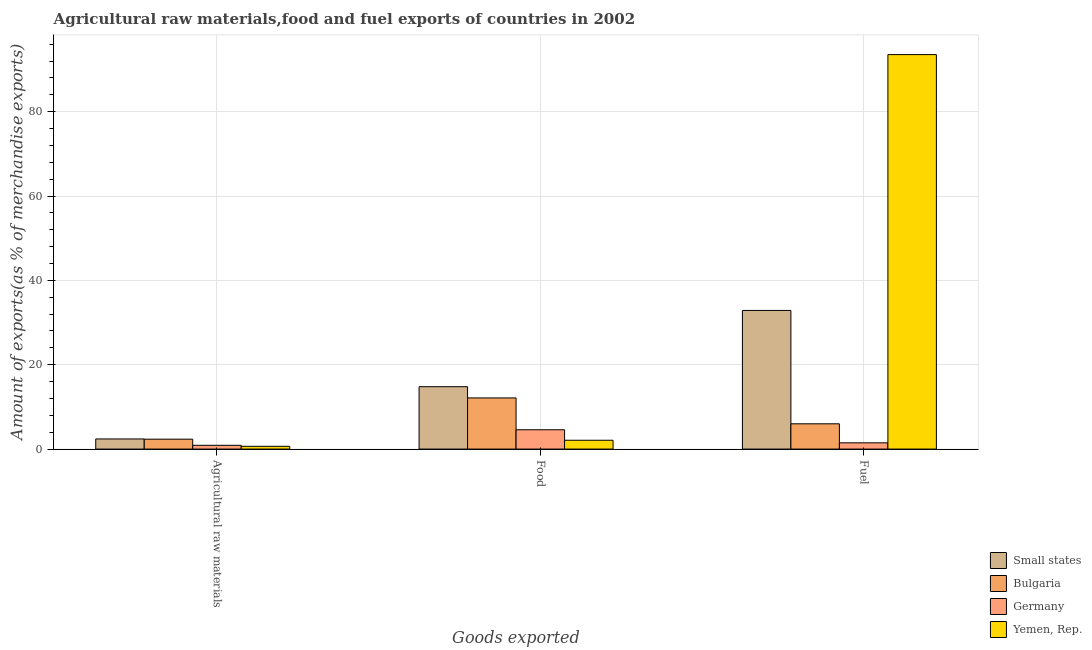How many different coloured bars are there?
Provide a short and direct response. 4. Are the number of bars per tick equal to the number of legend labels?
Provide a short and direct response. Yes. How many bars are there on the 2nd tick from the left?
Provide a short and direct response. 4. What is the label of the 3rd group of bars from the left?
Keep it short and to the point. Fuel. What is the percentage of raw materials exports in Germany?
Give a very brief answer. 0.9. Across all countries, what is the maximum percentage of food exports?
Your response must be concise. 14.79. Across all countries, what is the minimum percentage of fuel exports?
Ensure brevity in your answer.  1.48. In which country was the percentage of raw materials exports maximum?
Provide a succinct answer. Small states. In which country was the percentage of raw materials exports minimum?
Your answer should be very brief. Yemen, Rep. What is the total percentage of raw materials exports in the graph?
Your answer should be compact. 6.3. What is the difference between the percentage of food exports in Bulgaria and that in Germany?
Give a very brief answer. 7.55. What is the difference between the percentage of raw materials exports in Bulgaria and the percentage of food exports in Small states?
Your response must be concise. -12.45. What is the average percentage of food exports per country?
Give a very brief answer. 8.4. What is the difference between the percentage of food exports and percentage of raw materials exports in Bulgaria?
Provide a succinct answer. 9.78. What is the ratio of the percentage of food exports in Yemen, Rep. to that in Germany?
Offer a very short reply. 0.46. Is the percentage of food exports in Small states less than that in Germany?
Offer a very short reply. No. Is the difference between the percentage of food exports in Small states and Bulgaria greater than the difference between the percentage of raw materials exports in Small states and Bulgaria?
Offer a terse response. Yes. What is the difference between the highest and the second highest percentage of fuel exports?
Provide a succinct answer. 60.67. What is the difference between the highest and the lowest percentage of raw materials exports?
Make the answer very short. 1.75. What does the 4th bar from the left in Agricultural raw materials represents?
Offer a very short reply. Yemen, Rep. What does the 4th bar from the right in Fuel represents?
Keep it short and to the point. Small states. Is it the case that in every country, the sum of the percentage of raw materials exports and percentage of food exports is greater than the percentage of fuel exports?
Offer a terse response. No. What is the difference between two consecutive major ticks on the Y-axis?
Make the answer very short. 20. Are the values on the major ticks of Y-axis written in scientific E-notation?
Keep it short and to the point. No. Does the graph contain any zero values?
Give a very brief answer. No. How are the legend labels stacked?
Offer a terse response. Vertical. What is the title of the graph?
Offer a terse response. Agricultural raw materials,food and fuel exports of countries in 2002. What is the label or title of the X-axis?
Offer a very short reply. Goods exported. What is the label or title of the Y-axis?
Your response must be concise. Amount of exports(as % of merchandise exports). What is the Amount of exports(as % of merchandise exports) of Small states in Agricultural raw materials?
Your answer should be compact. 2.4. What is the Amount of exports(as % of merchandise exports) of Bulgaria in Agricultural raw materials?
Provide a short and direct response. 2.35. What is the Amount of exports(as % of merchandise exports) in Germany in Agricultural raw materials?
Your response must be concise. 0.9. What is the Amount of exports(as % of merchandise exports) in Yemen, Rep. in Agricultural raw materials?
Keep it short and to the point. 0.66. What is the Amount of exports(as % of merchandise exports) in Small states in Food?
Make the answer very short. 14.79. What is the Amount of exports(as % of merchandise exports) in Bulgaria in Food?
Give a very brief answer. 12.13. What is the Amount of exports(as % of merchandise exports) in Germany in Food?
Give a very brief answer. 4.58. What is the Amount of exports(as % of merchandise exports) of Yemen, Rep. in Food?
Offer a very short reply. 2.09. What is the Amount of exports(as % of merchandise exports) of Small states in Fuel?
Keep it short and to the point. 32.88. What is the Amount of exports(as % of merchandise exports) of Bulgaria in Fuel?
Your response must be concise. 5.99. What is the Amount of exports(as % of merchandise exports) in Germany in Fuel?
Your answer should be very brief. 1.48. What is the Amount of exports(as % of merchandise exports) in Yemen, Rep. in Fuel?
Ensure brevity in your answer.  93.54. Across all Goods exported, what is the maximum Amount of exports(as % of merchandise exports) of Small states?
Your answer should be compact. 32.88. Across all Goods exported, what is the maximum Amount of exports(as % of merchandise exports) in Bulgaria?
Provide a succinct answer. 12.13. Across all Goods exported, what is the maximum Amount of exports(as % of merchandise exports) in Germany?
Give a very brief answer. 4.58. Across all Goods exported, what is the maximum Amount of exports(as % of merchandise exports) of Yemen, Rep.?
Provide a short and direct response. 93.54. Across all Goods exported, what is the minimum Amount of exports(as % of merchandise exports) of Small states?
Your answer should be very brief. 2.4. Across all Goods exported, what is the minimum Amount of exports(as % of merchandise exports) of Bulgaria?
Make the answer very short. 2.35. Across all Goods exported, what is the minimum Amount of exports(as % of merchandise exports) of Germany?
Give a very brief answer. 0.9. Across all Goods exported, what is the minimum Amount of exports(as % of merchandise exports) in Yemen, Rep.?
Give a very brief answer. 0.66. What is the total Amount of exports(as % of merchandise exports) of Small states in the graph?
Make the answer very short. 50.07. What is the total Amount of exports(as % of merchandise exports) in Bulgaria in the graph?
Your response must be concise. 20.46. What is the total Amount of exports(as % of merchandise exports) in Germany in the graph?
Your response must be concise. 6.96. What is the total Amount of exports(as % of merchandise exports) of Yemen, Rep. in the graph?
Make the answer very short. 96.29. What is the difference between the Amount of exports(as % of merchandise exports) in Small states in Agricultural raw materials and that in Food?
Your response must be concise. -12.39. What is the difference between the Amount of exports(as % of merchandise exports) of Bulgaria in Agricultural raw materials and that in Food?
Keep it short and to the point. -9.78. What is the difference between the Amount of exports(as % of merchandise exports) in Germany in Agricultural raw materials and that in Food?
Your response must be concise. -3.69. What is the difference between the Amount of exports(as % of merchandise exports) of Yemen, Rep. in Agricultural raw materials and that in Food?
Make the answer very short. -1.43. What is the difference between the Amount of exports(as % of merchandise exports) of Small states in Agricultural raw materials and that in Fuel?
Give a very brief answer. -30.47. What is the difference between the Amount of exports(as % of merchandise exports) in Bulgaria in Agricultural raw materials and that in Fuel?
Provide a short and direct response. -3.64. What is the difference between the Amount of exports(as % of merchandise exports) in Germany in Agricultural raw materials and that in Fuel?
Offer a terse response. -0.59. What is the difference between the Amount of exports(as % of merchandise exports) of Yemen, Rep. in Agricultural raw materials and that in Fuel?
Give a very brief answer. -92.89. What is the difference between the Amount of exports(as % of merchandise exports) of Small states in Food and that in Fuel?
Your answer should be compact. -18.08. What is the difference between the Amount of exports(as % of merchandise exports) of Bulgaria in Food and that in Fuel?
Offer a very short reply. 6.14. What is the difference between the Amount of exports(as % of merchandise exports) of Germany in Food and that in Fuel?
Provide a succinct answer. 3.1. What is the difference between the Amount of exports(as % of merchandise exports) of Yemen, Rep. in Food and that in Fuel?
Your response must be concise. -91.45. What is the difference between the Amount of exports(as % of merchandise exports) of Small states in Agricultural raw materials and the Amount of exports(as % of merchandise exports) of Bulgaria in Food?
Your answer should be compact. -9.73. What is the difference between the Amount of exports(as % of merchandise exports) in Small states in Agricultural raw materials and the Amount of exports(as % of merchandise exports) in Germany in Food?
Make the answer very short. -2.18. What is the difference between the Amount of exports(as % of merchandise exports) of Small states in Agricultural raw materials and the Amount of exports(as % of merchandise exports) of Yemen, Rep. in Food?
Your answer should be very brief. 0.31. What is the difference between the Amount of exports(as % of merchandise exports) in Bulgaria in Agricultural raw materials and the Amount of exports(as % of merchandise exports) in Germany in Food?
Offer a very short reply. -2.23. What is the difference between the Amount of exports(as % of merchandise exports) of Bulgaria in Agricultural raw materials and the Amount of exports(as % of merchandise exports) of Yemen, Rep. in Food?
Ensure brevity in your answer.  0.26. What is the difference between the Amount of exports(as % of merchandise exports) in Germany in Agricultural raw materials and the Amount of exports(as % of merchandise exports) in Yemen, Rep. in Food?
Your answer should be compact. -1.19. What is the difference between the Amount of exports(as % of merchandise exports) of Small states in Agricultural raw materials and the Amount of exports(as % of merchandise exports) of Bulgaria in Fuel?
Provide a succinct answer. -3.59. What is the difference between the Amount of exports(as % of merchandise exports) in Small states in Agricultural raw materials and the Amount of exports(as % of merchandise exports) in Germany in Fuel?
Provide a short and direct response. 0.92. What is the difference between the Amount of exports(as % of merchandise exports) of Small states in Agricultural raw materials and the Amount of exports(as % of merchandise exports) of Yemen, Rep. in Fuel?
Provide a short and direct response. -91.14. What is the difference between the Amount of exports(as % of merchandise exports) of Bulgaria in Agricultural raw materials and the Amount of exports(as % of merchandise exports) of Germany in Fuel?
Your answer should be compact. 0.86. What is the difference between the Amount of exports(as % of merchandise exports) of Bulgaria in Agricultural raw materials and the Amount of exports(as % of merchandise exports) of Yemen, Rep. in Fuel?
Offer a terse response. -91.2. What is the difference between the Amount of exports(as % of merchandise exports) in Germany in Agricultural raw materials and the Amount of exports(as % of merchandise exports) in Yemen, Rep. in Fuel?
Provide a succinct answer. -92.65. What is the difference between the Amount of exports(as % of merchandise exports) of Small states in Food and the Amount of exports(as % of merchandise exports) of Bulgaria in Fuel?
Offer a very short reply. 8.8. What is the difference between the Amount of exports(as % of merchandise exports) in Small states in Food and the Amount of exports(as % of merchandise exports) in Germany in Fuel?
Provide a short and direct response. 13.31. What is the difference between the Amount of exports(as % of merchandise exports) of Small states in Food and the Amount of exports(as % of merchandise exports) of Yemen, Rep. in Fuel?
Ensure brevity in your answer.  -78.75. What is the difference between the Amount of exports(as % of merchandise exports) in Bulgaria in Food and the Amount of exports(as % of merchandise exports) in Germany in Fuel?
Your answer should be very brief. 10.65. What is the difference between the Amount of exports(as % of merchandise exports) in Bulgaria in Food and the Amount of exports(as % of merchandise exports) in Yemen, Rep. in Fuel?
Your response must be concise. -81.42. What is the difference between the Amount of exports(as % of merchandise exports) in Germany in Food and the Amount of exports(as % of merchandise exports) in Yemen, Rep. in Fuel?
Provide a short and direct response. -88.96. What is the average Amount of exports(as % of merchandise exports) of Small states per Goods exported?
Keep it short and to the point. 16.69. What is the average Amount of exports(as % of merchandise exports) in Bulgaria per Goods exported?
Ensure brevity in your answer.  6.82. What is the average Amount of exports(as % of merchandise exports) in Germany per Goods exported?
Provide a succinct answer. 2.32. What is the average Amount of exports(as % of merchandise exports) of Yemen, Rep. per Goods exported?
Your answer should be very brief. 32.1. What is the difference between the Amount of exports(as % of merchandise exports) of Small states and Amount of exports(as % of merchandise exports) of Bulgaria in Agricultural raw materials?
Ensure brevity in your answer.  0.06. What is the difference between the Amount of exports(as % of merchandise exports) in Small states and Amount of exports(as % of merchandise exports) in Germany in Agricultural raw materials?
Offer a terse response. 1.51. What is the difference between the Amount of exports(as % of merchandise exports) in Small states and Amount of exports(as % of merchandise exports) in Yemen, Rep. in Agricultural raw materials?
Ensure brevity in your answer.  1.75. What is the difference between the Amount of exports(as % of merchandise exports) of Bulgaria and Amount of exports(as % of merchandise exports) of Germany in Agricultural raw materials?
Your answer should be very brief. 1.45. What is the difference between the Amount of exports(as % of merchandise exports) in Bulgaria and Amount of exports(as % of merchandise exports) in Yemen, Rep. in Agricultural raw materials?
Make the answer very short. 1.69. What is the difference between the Amount of exports(as % of merchandise exports) in Germany and Amount of exports(as % of merchandise exports) in Yemen, Rep. in Agricultural raw materials?
Provide a short and direct response. 0.24. What is the difference between the Amount of exports(as % of merchandise exports) of Small states and Amount of exports(as % of merchandise exports) of Bulgaria in Food?
Your response must be concise. 2.67. What is the difference between the Amount of exports(as % of merchandise exports) of Small states and Amount of exports(as % of merchandise exports) of Germany in Food?
Your response must be concise. 10.21. What is the difference between the Amount of exports(as % of merchandise exports) of Small states and Amount of exports(as % of merchandise exports) of Yemen, Rep. in Food?
Your answer should be very brief. 12.7. What is the difference between the Amount of exports(as % of merchandise exports) in Bulgaria and Amount of exports(as % of merchandise exports) in Germany in Food?
Your answer should be compact. 7.55. What is the difference between the Amount of exports(as % of merchandise exports) of Bulgaria and Amount of exports(as % of merchandise exports) of Yemen, Rep. in Food?
Your answer should be compact. 10.04. What is the difference between the Amount of exports(as % of merchandise exports) in Germany and Amount of exports(as % of merchandise exports) in Yemen, Rep. in Food?
Make the answer very short. 2.49. What is the difference between the Amount of exports(as % of merchandise exports) in Small states and Amount of exports(as % of merchandise exports) in Bulgaria in Fuel?
Offer a very short reply. 26.88. What is the difference between the Amount of exports(as % of merchandise exports) of Small states and Amount of exports(as % of merchandise exports) of Germany in Fuel?
Offer a terse response. 31.39. What is the difference between the Amount of exports(as % of merchandise exports) of Small states and Amount of exports(as % of merchandise exports) of Yemen, Rep. in Fuel?
Give a very brief answer. -60.67. What is the difference between the Amount of exports(as % of merchandise exports) of Bulgaria and Amount of exports(as % of merchandise exports) of Germany in Fuel?
Your answer should be very brief. 4.51. What is the difference between the Amount of exports(as % of merchandise exports) in Bulgaria and Amount of exports(as % of merchandise exports) in Yemen, Rep. in Fuel?
Provide a succinct answer. -87.55. What is the difference between the Amount of exports(as % of merchandise exports) of Germany and Amount of exports(as % of merchandise exports) of Yemen, Rep. in Fuel?
Offer a very short reply. -92.06. What is the ratio of the Amount of exports(as % of merchandise exports) of Small states in Agricultural raw materials to that in Food?
Your answer should be very brief. 0.16. What is the ratio of the Amount of exports(as % of merchandise exports) in Bulgaria in Agricultural raw materials to that in Food?
Offer a terse response. 0.19. What is the ratio of the Amount of exports(as % of merchandise exports) of Germany in Agricultural raw materials to that in Food?
Offer a very short reply. 0.2. What is the ratio of the Amount of exports(as % of merchandise exports) of Yemen, Rep. in Agricultural raw materials to that in Food?
Your response must be concise. 0.31. What is the ratio of the Amount of exports(as % of merchandise exports) of Small states in Agricultural raw materials to that in Fuel?
Provide a short and direct response. 0.07. What is the ratio of the Amount of exports(as % of merchandise exports) of Bulgaria in Agricultural raw materials to that in Fuel?
Offer a very short reply. 0.39. What is the ratio of the Amount of exports(as % of merchandise exports) in Germany in Agricultural raw materials to that in Fuel?
Ensure brevity in your answer.  0.6. What is the ratio of the Amount of exports(as % of merchandise exports) of Yemen, Rep. in Agricultural raw materials to that in Fuel?
Ensure brevity in your answer.  0.01. What is the ratio of the Amount of exports(as % of merchandise exports) in Small states in Food to that in Fuel?
Give a very brief answer. 0.45. What is the ratio of the Amount of exports(as % of merchandise exports) in Bulgaria in Food to that in Fuel?
Your response must be concise. 2.02. What is the ratio of the Amount of exports(as % of merchandise exports) in Germany in Food to that in Fuel?
Make the answer very short. 3.09. What is the ratio of the Amount of exports(as % of merchandise exports) of Yemen, Rep. in Food to that in Fuel?
Give a very brief answer. 0.02. What is the difference between the highest and the second highest Amount of exports(as % of merchandise exports) in Small states?
Make the answer very short. 18.08. What is the difference between the highest and the second highest Amount of exports(as % of merchandise exports) in Bulgaria?
Provide a succinct answer. 6.14. What is the difference between the highest and the second highest Amount of exports(as % of merchandise exports) in Germany?
Provide a short and direct response. 3.1. What is the difference between the highest and the second highest Amount of exports(as % of merchandise exports) of Yemen, Rep.?
Your response must be concise. 91.45. What is the difference between the highest and the lowest Amount of exports(as % of merchandise exports) in Small states?
Give a very brief answer. 30.47. What is the difference between the highest and the lowest Amount of exports(as % of merchandise exports) in Bulgaria?
Make the answer very short. 9.78. What is the difference between the highest and the lowest Amount of exports(as % of merchandise exports) of Germany?
Your response must be concise. 3.69. What is the difference between the highest and the lowest Amount of exports(as % of merchandise exports) of Yemen, Rep.?
Ensure brevity in your answer.  92.89. 